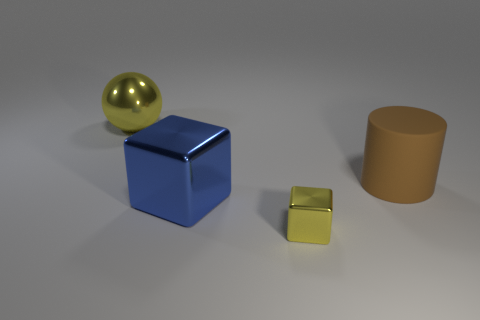The metallic ball that is the same color as the small shiny thing is what size?
Offer a very short reply. Large. Are there any other things that have the same color as the small metallic thing?
Ensure brevity in your answer.  Yes. There is a large thing behind the large brown matte thing; does it have the same color as the tiny block?
Provide a short and direct response. Yes. There is a large metallic thing that is in front of the brown cylinder; does it have the same shape as the small yellow object?
Your answer should be compact. Yes. There is another object that is the same color as the small object; what shape is it?
Ensure brevity in your answer.  Sphere. Are there any cubes that have the same color as the big ball?
Keep it short and to the point. Yes. What is the shape of the big thing that is behind the cylinder?
Your response must be concise. Sphere. How many objects are to the right of the big blue cube and left of the large blue object?
Offer a very short reply. 0. How many other things are the same size as the matte cylinder?
Your response must be concise. 2. Do the big thing in front of the rubber cylinder and the yellow shiny thing in front of the brown object have the same shape?
Provide a succinct answer. Yes. 